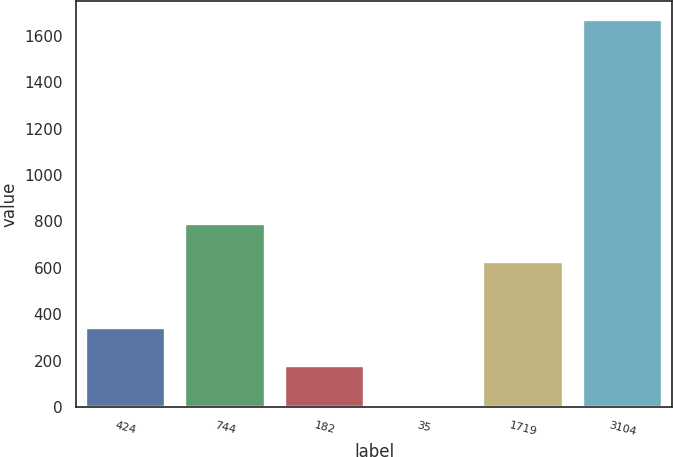Convert chart. <chart><loc_0><loc_0><loc_500><loc_500><bar_chart><fcel>424<fcel>744<fcel>182<fcel>35<fcel>1719<fcel>3104<nl><fcel>341.66<fcel>790.33<fcel>176.03<fcel>10.4<fcel>624.7<fcel>1666.7<nl></chart> 